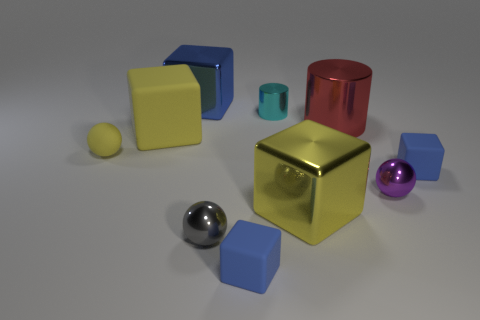How many blue blocks must be subtracted to get 1 blue blocks? 2 Subtract all small shiny spheres. How many spheres are left? 1 Subtract all yellow blocks. How many blocks are left? 3 Subtract all purple balls. Subtract all green cylinders. How many balls are left? 2 Subtract all green cubes. How many blue spheres are left? 0 Subtract all tiny purple shiny blocks. Subtract all blue rubber cubes. How many objects are left? 8 Add 6 red cylinders. How many red cylinders are left? 7 Add 1 blue rubber things. How many blue rubber things exist? 3 Subtract 0 green cylinders. How many objects are left? 10 Subtract all cylinders. How many objects are left? 8 